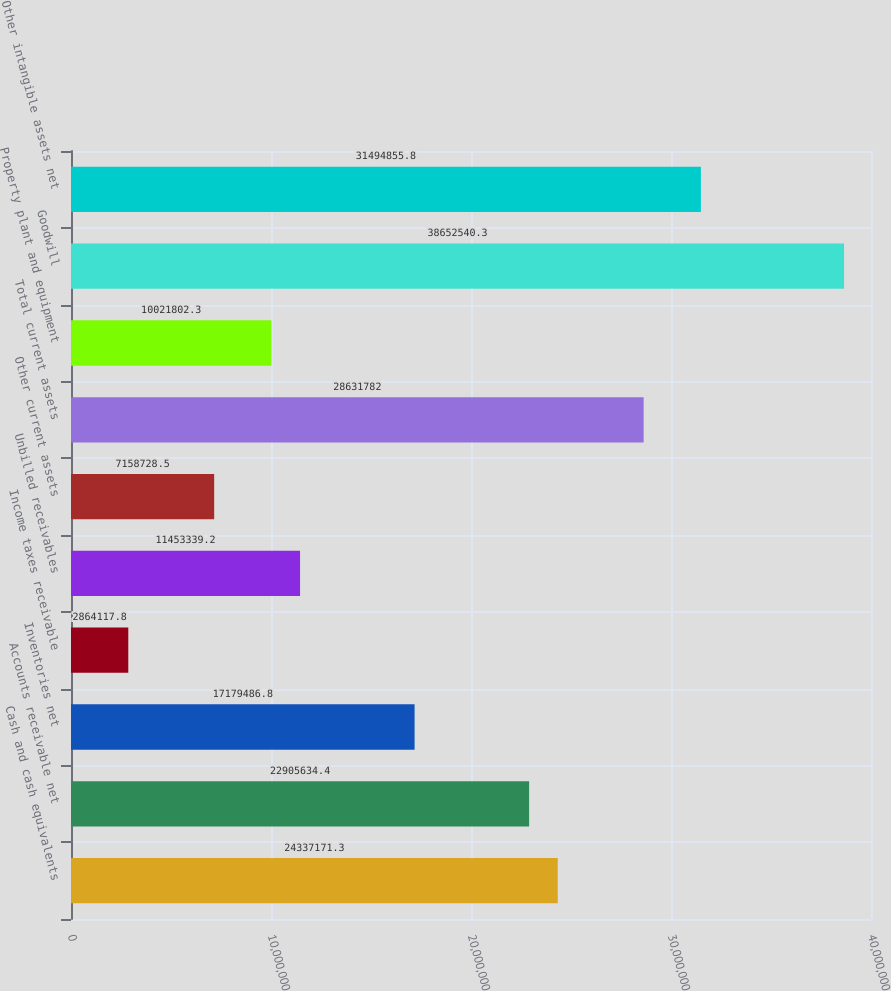Convert chart to OTSL. <chart><loc_0><loc_0><loc_500><loc_500><bar_chart><fcel>Cash and cash equivalents<fcel>Accounts receivable net<fcel>Inventories net<fcel>Income taxes receivable<fcel>Unbilled receivables<fcel>Other current assets<fcel>Total current assets<fcel>Property plant and equipment<fcel>Goodwill<fcel>Other intangible assets net<nl><fcel>2.43372e+07<fcel>2.29056e+07<fcel>1.71795e+07<fcel>2.86412e+06<fcel>1.14533e+07<fcel>7.15873e+06<fcel>2.86318e+07<fcel>1.00218e+07<fcel>3.86525e+07<fcel>3.14949e+07<nl></chart> 